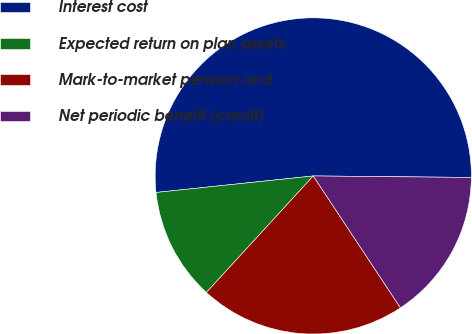<chart> <loc_0><loc_0><loc_500><loc_500><pie_chart><fcel>Interest cost<fcel>Expected return on plan assets<fcel>Mark-to-market pension and<fcel>Net periodic benefit (credit)<nl><fcel>51.82%<fcel>11.52%<fcel>21.11%<fcel>15.55%<nl></chart> 